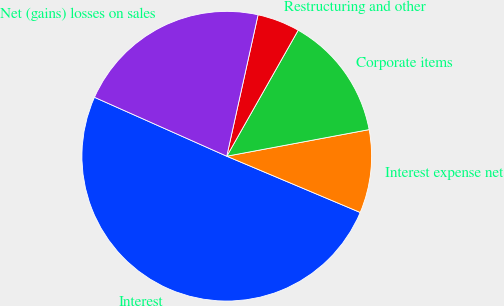<chart> <loc_0><loc_0><loc_500><loc_500><pie_chart><fcel>Interest<fcel>Interest expense net<fcel>Corporate items<fcel>Restructuring and other<fcel>Net (gains) losses on sales<nl><fcel>50.32%<fcel>9.29%<fcel>13.85%<fcel>4.74%<fcel>21.8%<nl></chart> 